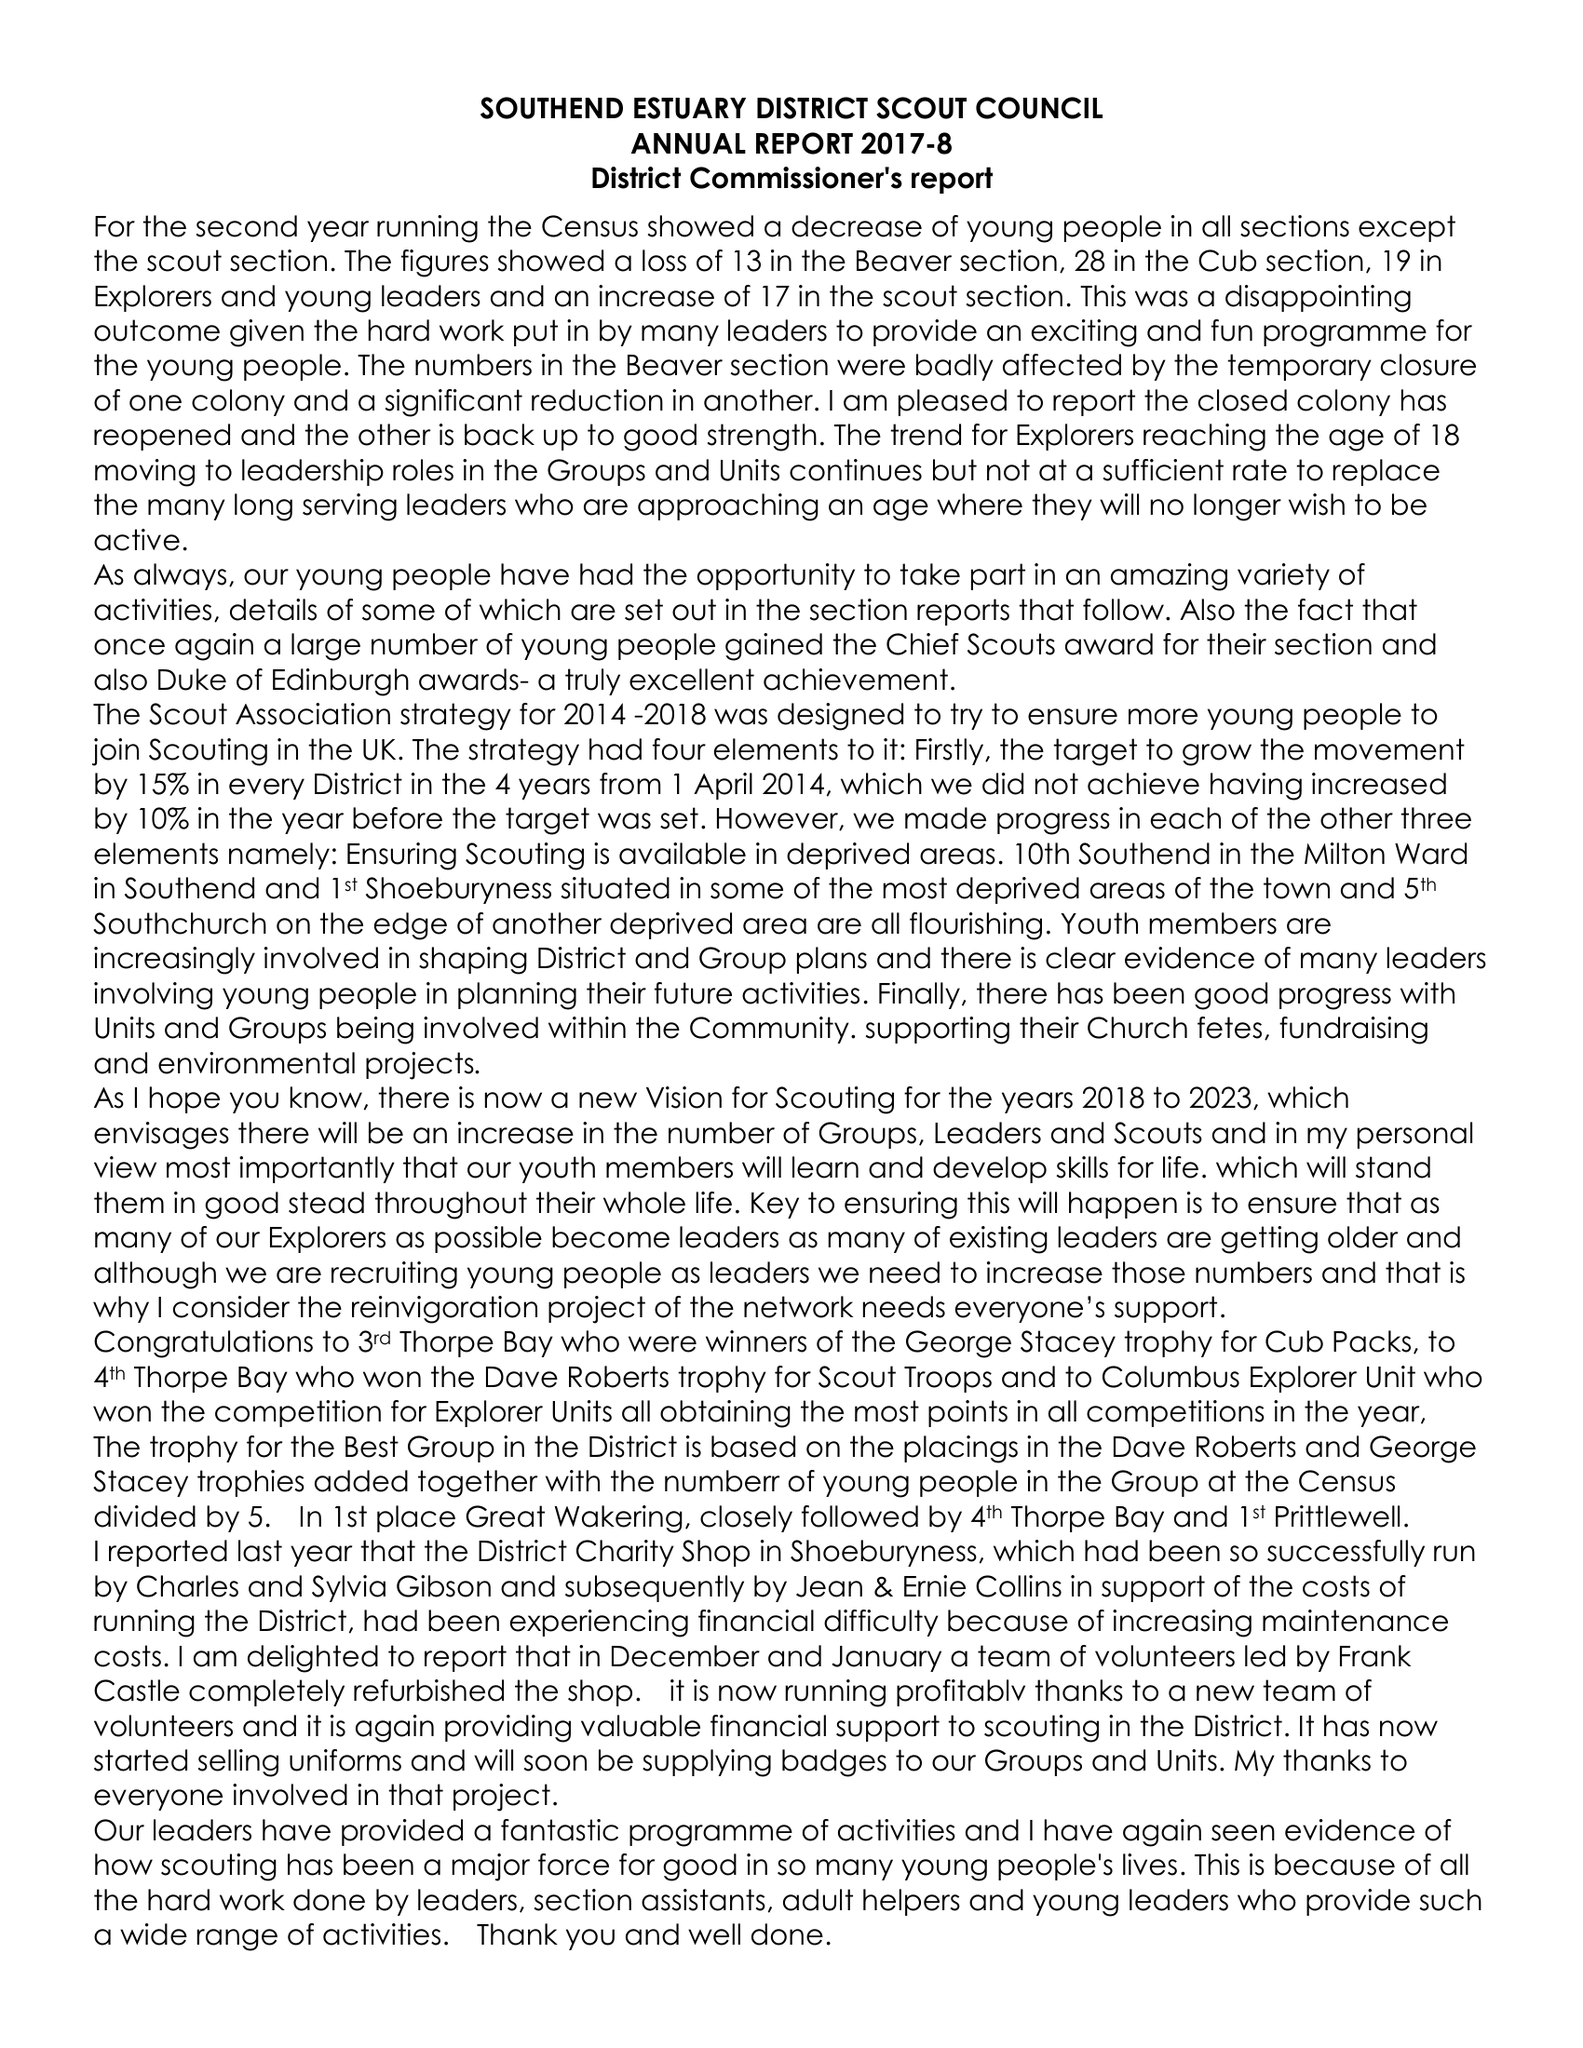What is the value for the report_date?
Answer the question using a single word or phrase. 2018-03-31 